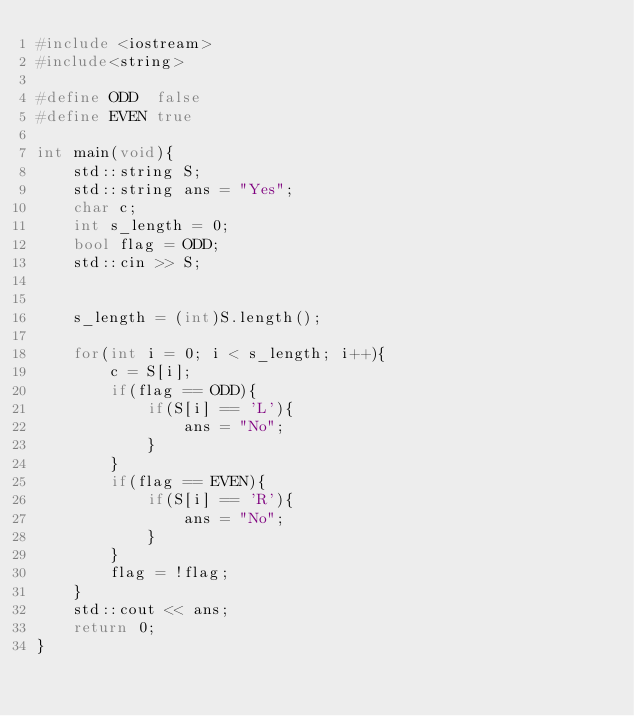Convert code to text. <code><loc_0><loc_0><loc_500><loc_500><_C++_>#include <iostream>
#include<string>

#define ODD  false
#define EVEN true

int main(void){
    std::string S;
    std::string ans = "Yes";
    char c;
    int s_length = 0;
    bool flag = ODD;
    std::cin >> S;
    

    s_length = (int)S.length();

    for(int i = 0; i < s_length; i++){
        c = S[i];
        if(flag == ODD){
            if(S[i] == 'L'){
                ans = "No";
            }
        }
        if(flag == EVEN){
            if(S[i] == 'R'){
                ans = "No";
            }
        }
        flag = !flag;
    }
    std::cout << ans;
    return 0;
}</code> 